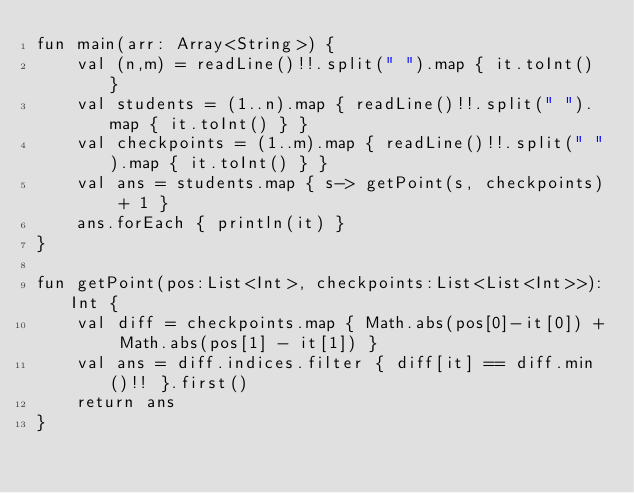Convert code to text. <code><loc_0><loc_0><loc_500><loc_500><_Kotlin_>fun main(arr: Array<String>) {
    val (n,m) = readLine()!!.split(" ").map { it.toInt() }
    val students = (1..n).map { readLine()!!.split(" ").map { it.toInt() } }
    val checkpoints = (1..m).map { readLine()!!.split(" ").map { it.toInt() } }
    val ans = students.map { s-> getPoint(s, checkpoints) + 1 }
    ans.forEach { println(it) }
}

fun getPoint(pos:List<Int>, checkpoints:List<List<Int>>):Int {
    val diff = checkpoints.map { Math.abs(pos[0]-it[0]) + Math.abs(pos[1] - it[1]) }
    val ans = diff.indices.filter { diff[it] == diff.min()!! }.first()
    return ans
}</code> 